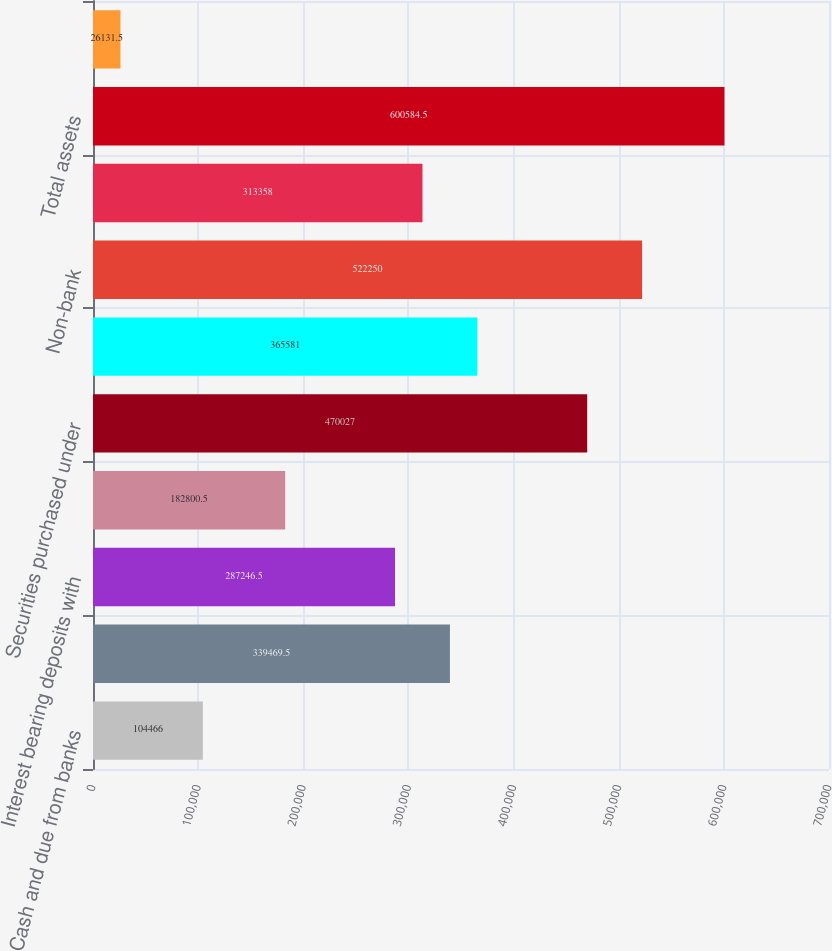Convert chart to OTSL. <chart><loc_0><loc_0><loc_500><loc_500><bar_chart><fcel>Cash and due from banks<fcel>Deposits with banking<fcel>Interest bearing deposits with<fcel>Trading assets at fair value<fcel>Securities purchased under<fcel>Bank and bank holding company<fcel>Non-bank<fcel>Other assets<fcel>Total assets<fcel>Commercial paper and other<nl><fcel>104466<fcel>339470<fcel>287246<fcel>182800<fcel>470027<fcel>365581<fcel>522250<fcel>313358<fcel>600584<fcel>26131.5<nl></chart> 